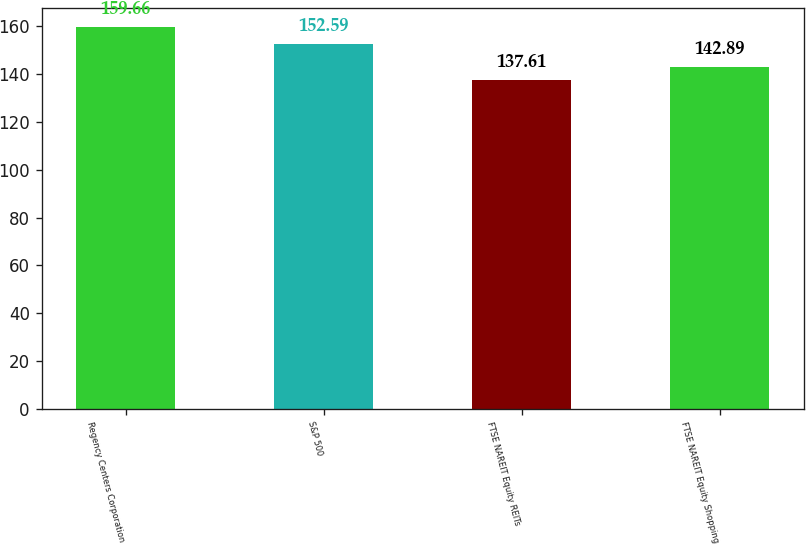Convert chart. <chart><loc_0><loc_0><loc_500><loc_500><bar_chart><fcel>Regency Centers Corporation<fcel>S&P 500<fcel>FTSE NAREIT Equity REITs<fcel>FTSE NAREIT Equity Shopping<nl><fcel>159.66<fcel>152.59<fcel>137.61<fcel>142.89<nl></chart> 